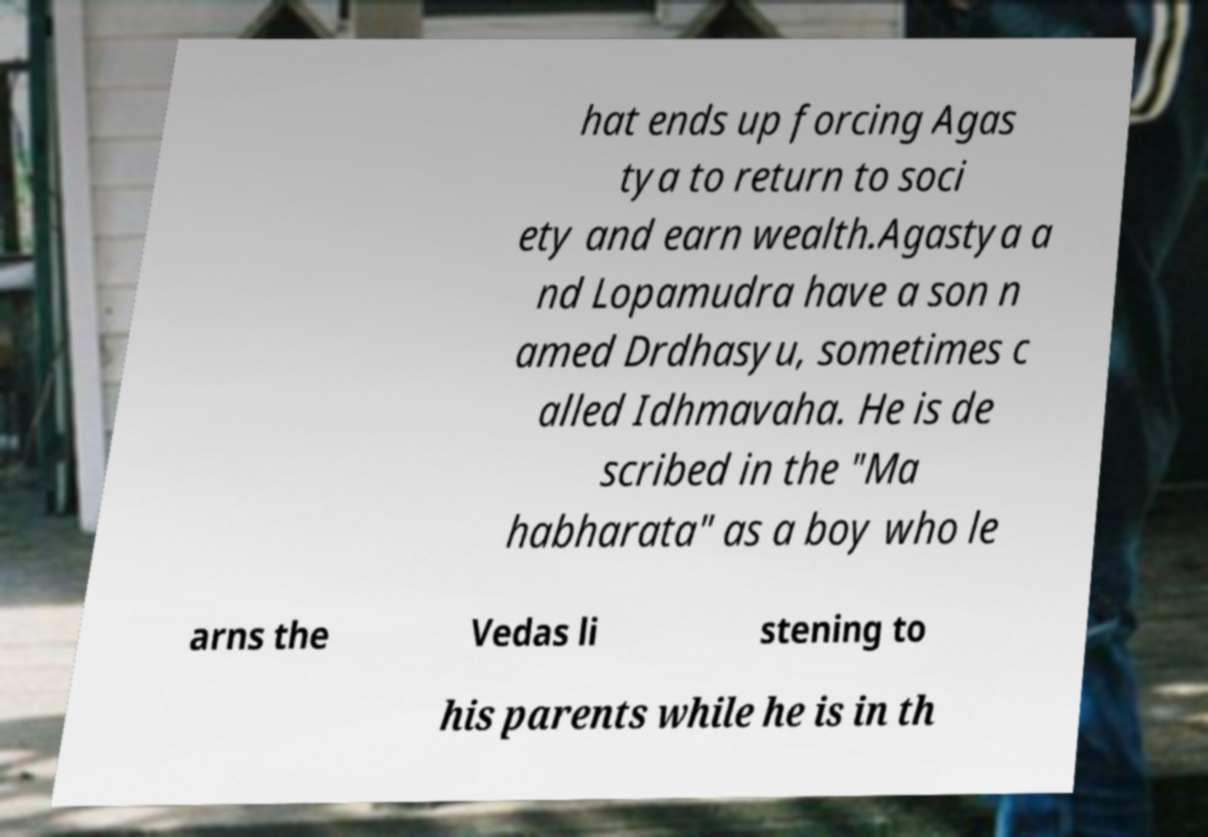Please read and relay the text visible in this image. What does it say? hat ends up forcing Agas tya to return to soci ety and earn wealth.Agastya a nd Lopamudra have a son n amed Drdhasyu, sometimes c alled Idhmavaha. He is de scribed in the "Ma habharata" as a boy who le arns the Vedas li stening to his parents while he is in th 